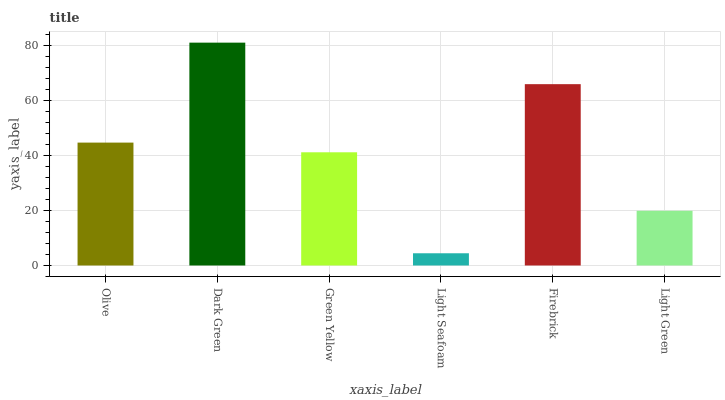Is Light Seafoam the minimum?
Answer yes or no. Yes. Is Dark Green the maximum?
Answer yes or no. Yes. Is Green Yellow the minimum?
Answer yes or no. No. Is Green Yellow the maximum?
Answer yes or no. No. Is Dark Green greater than Green Yellow?
Answer yes or no. Yes. Is Green Yellow less than Dark Green?
Answer yes or no. Yes. Is Green Yellow greater than Dark Green?
Answer yes or no. No. Is Dark Green less than Green Yellow?
Answer yes or no. No. Is Olive the high median?
Answer yes or no. Yes. Is Green Yellow the low median?
Answer yes or no. Yes. Is Light Seafoam the high median?
Answer yes or no. No. Is Dark Green the low median?
Answer yes or no. No. 